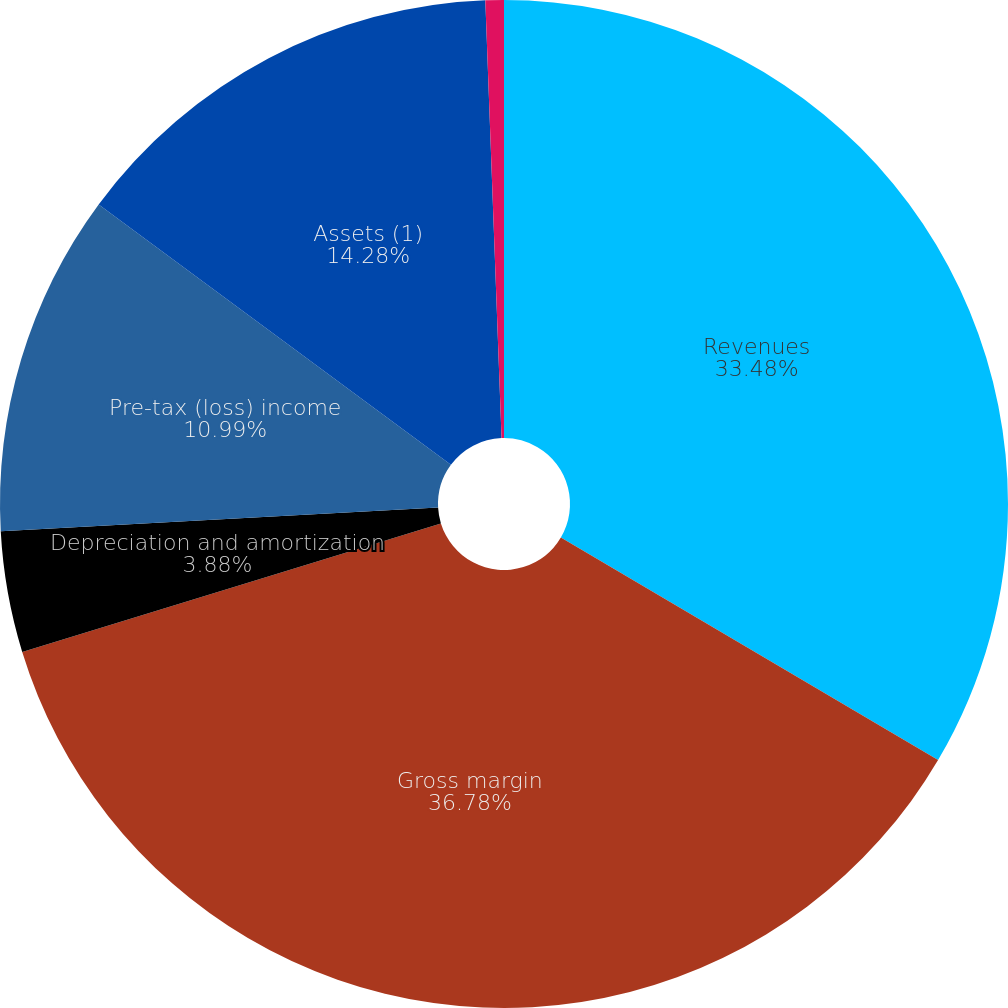Convert chart. <chart><loc_0><loc_0><loc_500><loc_500><pie_chart><fcel>Revenues<fcel>Gross margin<fcel>Depreciation and amortization<fcel>Pre-tax (loss) income<fcel>Assets (1)<fcel>Cash paid for property and<nl><fcel>33.48%<fcel>36.77%<fcel>3.88%<fcel>10.99%<fcel>14.28%<fcel>0.59%<nl></chart> 